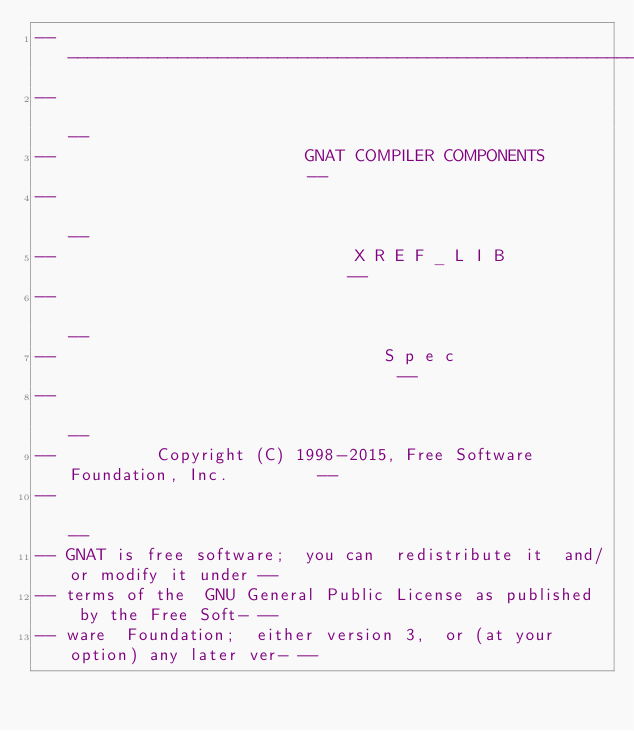<code> <loc_0><loc_0><loc_500><loc_500><_Ada_>------------------------------------------------------------------------------
--                                                                          --
--                         GNAT COMPILER COMPONENTS                         --
--                                                                          --
--                              X R E F _ L I B                             --
--                                                                          --
--                                 S p e c                                  --
--                                                                          --
--          Copyright (C) 1998-2015, Free Software Foundation, Inc.         --
--                                                                          --
-- GNAT is free software;  you can  redistribute it  and/or modify it under --
-- terms of the  GNU General Public License as published  by the Free Soft- --
-- ware  Foundation;  either version 3,  or (at your option) any later ver- --</code> 